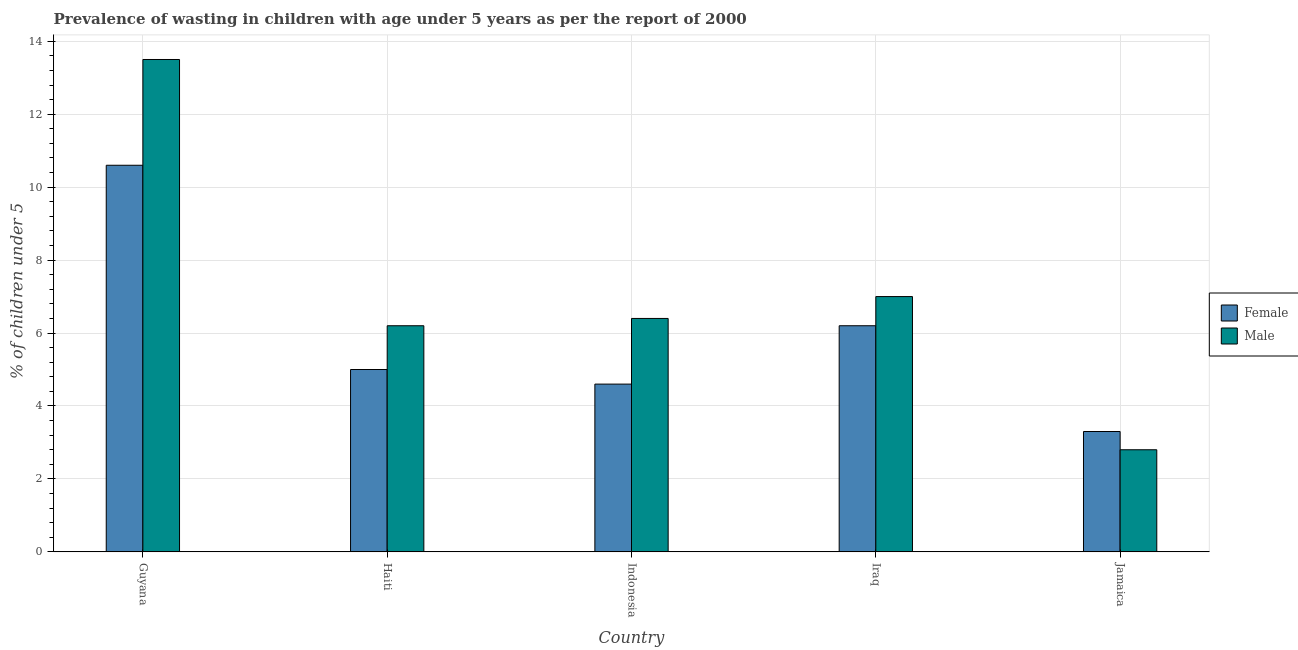How many different coloured bars are there?
Make the answer very short. 2. Are the number of bars per tick equal to the number of legend labels?
Keep it short and to the point. Yes. Are the number of bars on each tick of the X-axis equal?
Your answer should be compact. Yes. How many bars are there on the 3rd tick from the left?
Your answer should be compact. 2. How many bars are there on the 2nd tick from the right?
Provide a succinct answer. 2. What is the label of the 1st group of bars from the left?
Offer a terse response. Guyana. What is the percentage of undernourished female children in Indonesia?
Your answer should be very brief. 4.6. Across all countries, what is the maximum percentage of undernourished male children?
Ensure brevity in your answer.  13.5. Across all countries, what is the minimum percentage of undernourished female children?
Your answer should be very brief. 3.3. In which country was the percentage of undernourished male children maximum?
Your answer should be very brief. Guyana. In which country was the percentage of undernourished female children minimum?
Provide a succinct answer. Jamaica. What is the total percentage of undernourished female children in the graph?
Make the answer very short. 29.7. What is the difference between the percentage of undernourished female children in Guyana and that in Iraq?
Ensure brevity in your answer.  4.4. What is the difference between the percentage of undernourished male children in Indonesia and the percentage of undernourished female children in Iraq?
Your answer should be compact. 0.2. What is the average percentage of undernourished female children per country?
Offer a very short reply. 5.94. What is the difference between the percentage of undernourished male children and percentage of undernourished female children in Guyana?
Keep it short and to the point. 2.9. What is the ratio of the percentage of undernourished male children in Indonesia to that in Iraq?
Offer a very short reply. 0.91. Is the difference between the percentage of undernourished male children in Haiti and Jamaica greater than the difference between the percentage of undernourished female children in Haiti and Jamaica?
Offer a terse response. Yes. What is the difference between the highest and the lowest percentage of undernourished male children?
Your response must be concise. 10.7. What does the 1st bar from the left in Jamaica represents?
Your answer should be very brief. Female. What does the 2nd bar from the right in Guyana represents?
Ensure brevity in your answer.  Female. How many bars are there?
Your response must be concise. 10. Are all the bars in the graph horizontal?
Provide a short and direct response. No. What is the difference between two consecutive major ticks on the Y-axis?
Your response must be concise. 2. Are the values on the major ticks of Y-axis written in scientific E-notation?
Provide a succinct answer. No. Does the graph contain any zero values?
Ensure brevity in your answer.  No. Does the graph contain grids?
Ensure brevity in your answer.  Yes. Where does the legend appear in the graph?
Your answer should be very brief. Center right. How are the legend labels stacked?
Give a very brief answer. Vertical. What is the title of the graph?
Ensure brevity in your answer.  Prevalence of wasting in children with age under 5 years as per the report of 2000. What is the label or title of the X-axis?
Offer a very short reply. Country. What is the label or title of the Y-axis?
Your answer should be very brief.  % of children under 5. What is the  % of children under 5 of Female in Guyana?
Your answer should be compact. 10.6. What is the  % of children under 5 in Male in Guyana?
Make the answer very short. 13.5. What is the  % of children under 5 in Female in Haiti?
Your answer should be very brief. 5. What is the  % of children under 5 in Male in Haiti?
Your response must be concise. 6.2. What is the  % of children under 5 in Female in Indonesia?
Your response must be concise. 4.6. What is the  % of children under 5 in Male in Indonesia?
Make the answer very short. 6.4. What is the  % of children under 5 of Female in Iraq?
Provide a short and direct response. 6.2. What is the  % of children under 5 of Female in Jamaica?
Provide a succinct answer. 3.3. What is the  % of children under 5 of Male in Jamaica?
Provide a succinct answer. 2.8. Across all countries, what is the maximum  % of children under 5 in Female?
Provide a succinct answer. 10.6. Across all countries, what is the minimum  % of children under 5 in Female?
Your response must be concise. 3.3. Across all countries, what is the minimum  % of children under 5 in Male?
Ensure brevity in your answer.  2.8. What is the total  % of children under 5 in Female in the graph?
Your answer should be very brief. 29.7. What is the total  % of children under 5 of Male in the graph?
Make the answer very short. 35.9. What is the difference between the  % of children under 5 of Female in Guyana and that in Jamaica?
Give a very brief answer. 7.3. What is the difference between the  % of children under 5 of Female in Haiti and that in Indonesia?
Offer a very short reply. 0.4. What is the difference between the  % of children under 5 in Male in Haiti and that in Indonesia?
Your response must be concise. -0.2. What is the difference between the  % of children under 5 in Female in Haiti and that in Iraq?
Your answer should be very brief. -1.2. What is the difference between the  % of children under 5 of Male in Haiti and that in Jamaica?
Make the answer very short. 3.4. What is the difference between the  % of children under 5 in Female in Indonesia and that in Iraq?
Offer a very short reply. -1.6. What is the difference between the  % of children under 5 of Male in Indonesia and that in Jamaica?
Provide a succinct answer. 3.6. What is the difference between the  % of children under 5 of Female in Iraq and that in Jamaica?
Your answer should be compact. 2.9. What is the difference between the  % of children under 5 of Male in Iraq and that in Jamaica?
Keep it short and to the point. 4.2. What is the difference between the  % of children under 5 of Female in Guyana and the  % of children under 5 of Male in Iraq?
Ensure brevity in your answer.  3.6. What is the difference between the  % of children under 5 in Female in Guyana and the  % of children under 5 in Male in Jamaica?
Give a very brief answer. 7.8. What is the difference between the  % of children under 5 in Female in Haiti and the  % of children under 5 in Male in Indonesia?
Keep it short and to the point. -1.4. What is the difference between the  % of children under 5 in Female in Haiti and the  % of children under 5 in Male in Jamaica?
Your answer should be very brief. 2.2. What is the difference between the  % of children under 5 of Female in Indonesia and the  % of children under 5 of Male in Iraq?
Provide a short and direct response. -2.4. What is the difference between the  % of children under 5 of Female in Indonesia and the  % of children under 5 of Male in Jamaica?
Your response must be concise. 1.8. What is the average  % of children under 5 in Female per country?
Provide a short and direct response. 5.94. What is the average  % of children under 5 of Male per country?
Provide a succinct answer. 7.18. What is the difference between the  % of children under 5 of Female and  % of children under 5 of Male in Iraq?
Ensure brevity in your answer.  -0.8. What is the difference between the  % of children under 5 in Female and  % of children under 5 in Male in Jamaica?
Provide a short and direct response. 0.5. What is the ratio of the  % of children under 5 of Female in Guyana to that in Haiti?
Your answer should be very brief. 2.12. What is the ratio of the  % of children under 5 of Male in Guyana to that in Haiti?
Make the answer very short. 2.18. What is the ratio of the  % of children under 5 in Female in Guyana to that in Indonesia?
Make the answer very short. 2.3. What is the ratio of the  % of children under 5 in Male in Guyana to that in Indonesia?
Provide a succinct answer. 2.11. What is the ratio of the  % of children under 5 of Female in Guyana to that in Iraq?
Provide a succinct answer. 1.71. What is the ratio of the  % of children under 5 in Male in Guyana to that in Iraq?
Ensure brevity in your answer.  1.93. What is the ratio of the  % of children under 5 of Female in Guyana to that in Jamaica?
Your answer should be very brief. 3.21. What is the ratio of the  % of children under 5 of Male in Guyana to that in Jamaica?
Ensure brevity in your answer.  4.82. What is the ratio of the  % of children under 5 in Female in Haiti to that in Indonesia?
Your response must be concise. 1.09. What is the ratio of the  % of children under 5 of Male in Haiti to that in Indonesia?
Your answer should be very brief. 0.97. What is the ratio of the  % of children under 5 in Female in Haiti to that in Iraq?
Keep it short and to the point. 0.81. What is the ratio of the  % of children under 5 in Male in Haiti to that in Iraq?
Provide a succinct answer. 0.89. What is the ratio of the  % of children under 5 of Female in Haiti to that in Jamaica?
Provide a succinct answer. 1.52. What is the ratio of the  % of children under 5 in Male in Haiti to that in Jamaica?
Provide a succinct answer. 2.21. What is the ratio of the  % of children under 5 of Female in Indonesia to that in Iraq?
Your response must be concise. 0.74. What is the ratio of the  % of children under 5 of Male in Indonesia to that in Iraq?
Your response must be concise. 0.91. What is the ratio of the  % of children under 5 in Female in Indonesia to that in Jamaica?
Provide a succinct answer. 1.39. What is the ratio of the  % of children under 5 in Male in Indonesia to that in Jamaica?
Your response must be concise. 2.29. What is the ratio of the  % of children under 5 of Female in Iraq to that in Jamaica?
Keep it short and to the point. 1.88. What is the difference between the highest and the second highest  % of children under 5 in Female?
Offer a very short reply. 4.4. What is the difference between the highest and the second highest  % of children under 5 of Male?
Give a very brief answer. 6.5. What is the difference between the highest and the lowest  % of children under 5 of Female?
Your response must be concise. 7.3. What is the difference between the highest and the lowest  % of children under 5 of Male?
Give a very brief answer. 10.7. 